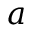<formula> <loc_0><loc_0><loc_500><loc_500>a</formula> 